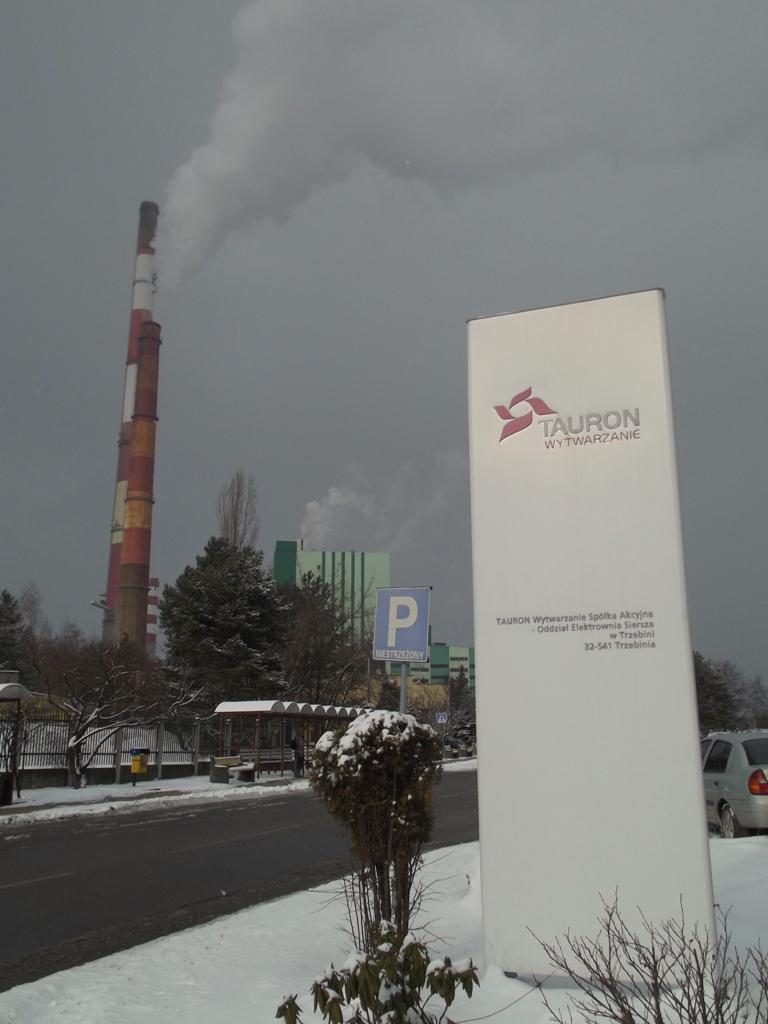Can you describe this image briefly? In this picture I can see the road, side there are some trees, boards fully covered with snow. 